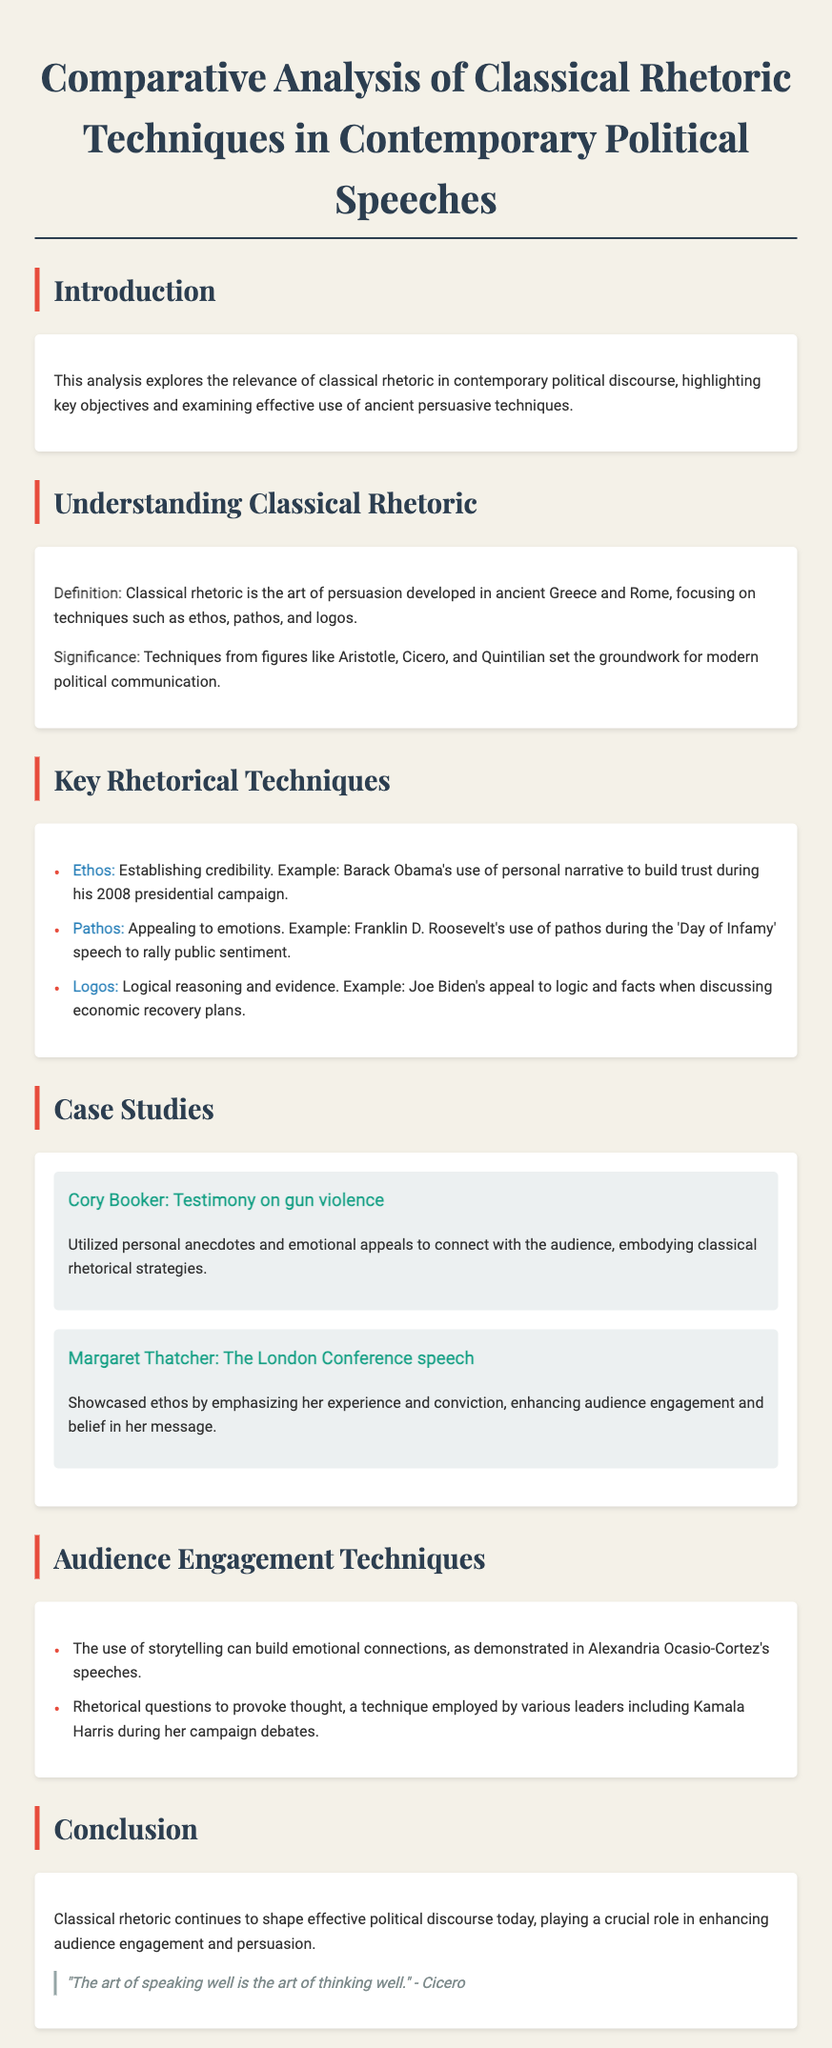What is the title of the document? The title is stated clearly at the beginning of the document and reflects its main theme.
Answer: Comparative Analysis of Classical Rhetoric Techniques in Contemporary Political Speeches Which ancient rhetorician is quoted in the conclusion? The document includes a quote from Cicero in the conclusion section.
Answer: Cicero What rhetorical technique emphasizes emotional appeal? The text lists various rhetorical techniques, and emotional appeal is specifically described as a key technique.
Answer: Pathos Which contemporary political figure utilized personal anecdotes in their speech? The document mentions Cory Booker specifically for using personal anecdotes to connect with the audience.
Answer: Cory Booker In what year did Barack Obama run his presidential campaign referenced in the document? The document refers to Barack Obama's campaign during a specific year mentioned within the text.
Answer: 2008 What is the main theme of the introduction? The introduction highlights the objectives of the analysis and the relevance of rhetorical techniques in political speeches.
Answer: Relevance of classical rhetoric Which political figure's speech is associated with the 'Day of Infamy'? The document provides a specific example of a speech tied to a historical event and identifies a political figure in connection to it.
Answer: Franklin D. Roosevelt What does the term 'ethos' refer to in the context of the document? The document explains that ethos is a rhetorical technique that establishes credibility.
Answer: Establishing credibility 